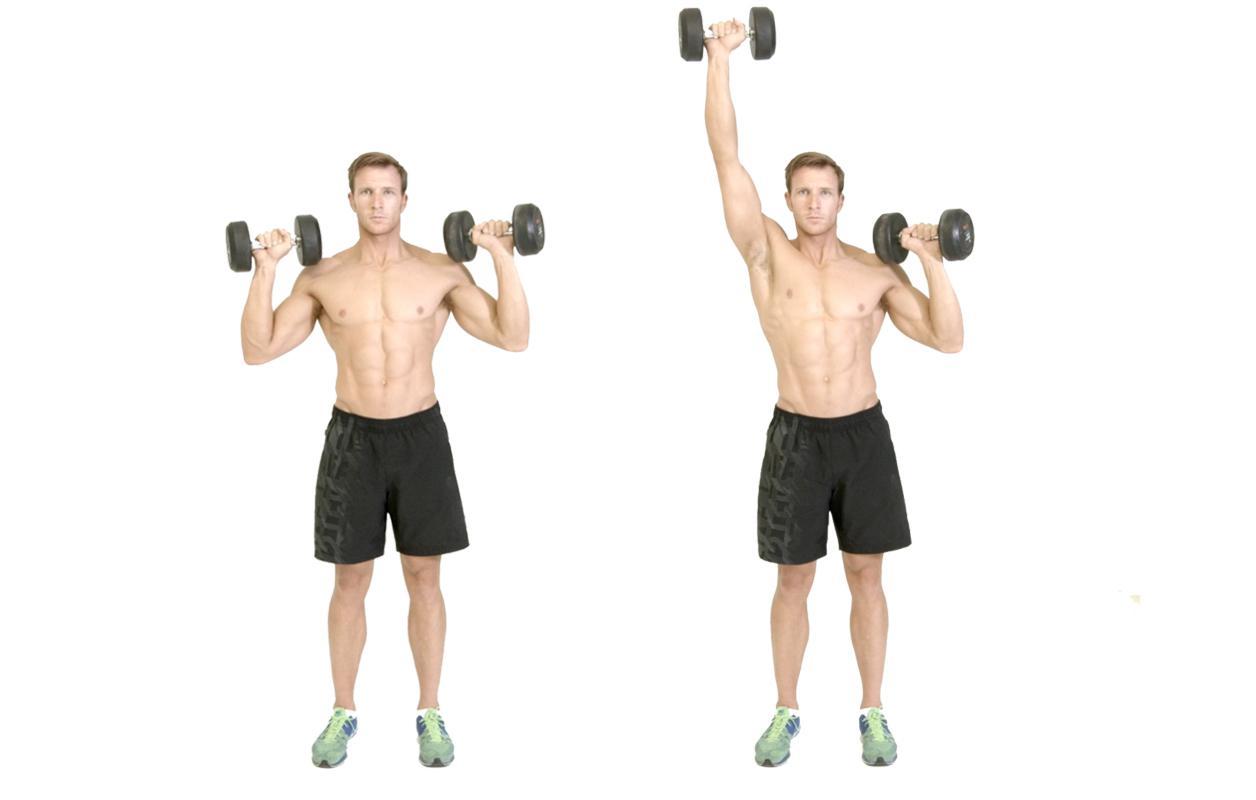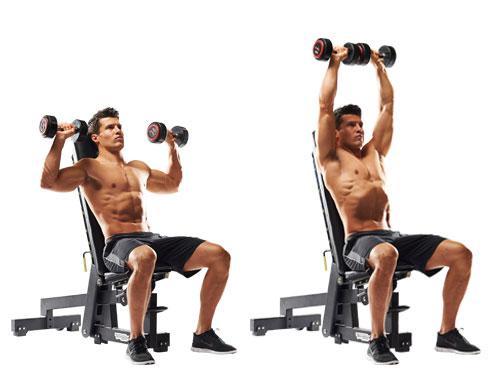The first image is the image on the left, the second image is the image on the right. Given the left and right images, does the statement "The left image shows a female working out." hold true? Answer yes or no. No. 